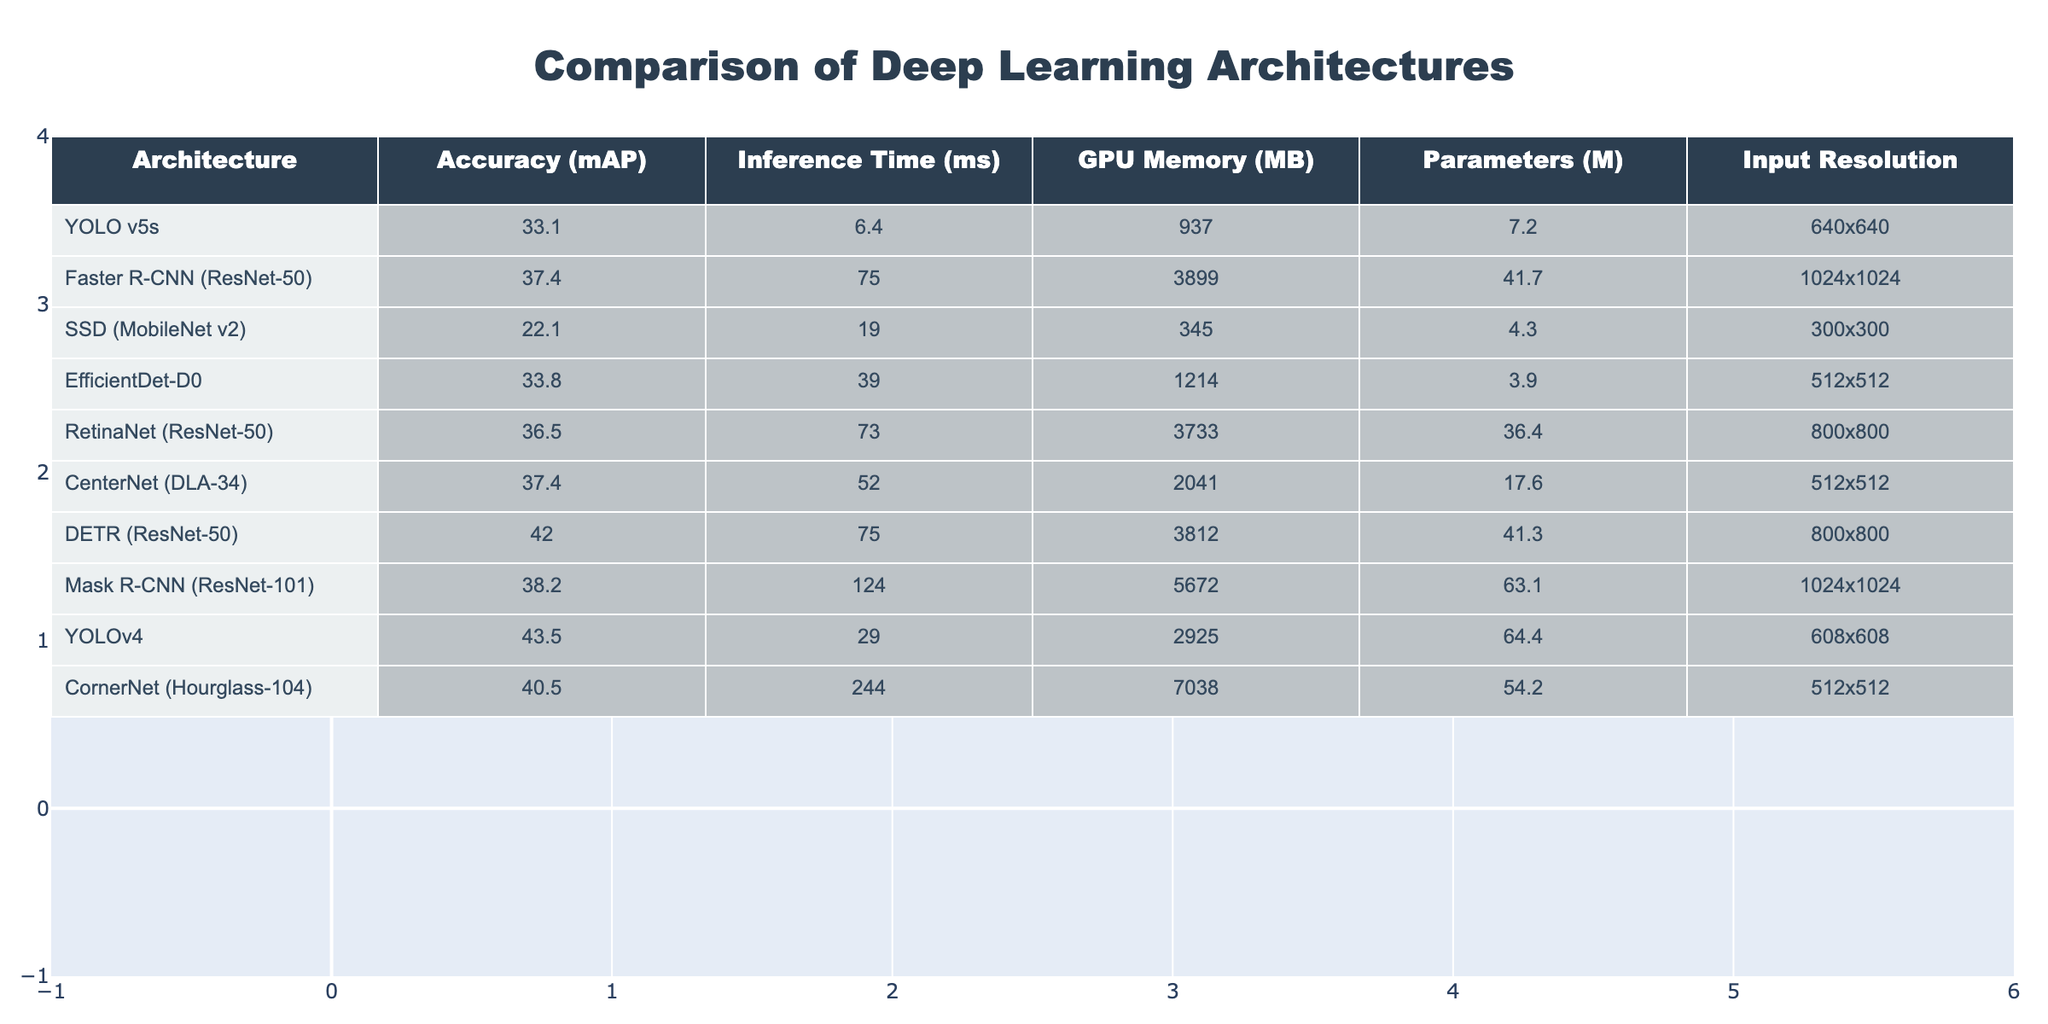What is the accuracy of YOLOv4? The table directly lists the accuracy for YOLOv4 as 43.5 mAP.
Answer: 43.5 Which architecture has the fastest inference time? By examining the 'Inference Time (ms)' column, YOLO v5s shows the lowest inference time of 6.4 ms compared to the other architectures.
Answer: YOLO v5s What is the range of GPU memory required among these architectures? The 'GPU Memory (MB)' column shows a minimum of 345 MB (SSD - MobileNet v2) and a maximum of 7038 MB (CornerNet - Hourglass-104), hence the range is 345 to 7038 MB.
Answer: 345 to 7038 MB How many architectures have an accuracy greater than 40? By referring to the 'Accuracy (mAP)' column, the architectures with accuracy greater than 40 are YOLOv4 (43.5), DETR (42.0), and CornerNet (40.5). Therefore, there are three such architectures.
Answer: 3 What is the average inference time for architectures with accuracy above 35? First, filter architectures with an accuracy above 35: Faster R-CNN (75.0), RetinaNet (73.0), CenterNet (52.0), MASK R-CNN (124.0), DECT (75.0), YOLOv4 (29.0) and exclude those below 35. The inference times for these are (75.0 + 73.0 + 52.0 + 75.0 + 29.0) = 304.0 ms and there are 5 architectures. The average is 304.0/5 = 60.8 ms.
Answer: 60.8 ms Is there any architecture with more than 60 million parameters? Considering the 'Parameters (M)' column, the only architecture with more than 60 million parameters is Mask R-CNN (ResNet-101), which has 63.1 M. Thus, the answer is yes.
Answer: Yes Which architecture achieves the best accuracy relative to its inference time? To identify the best accuracy relative to inference time, compare the accuracy to inference time ratios. YOLOv4 offers 43.5/29.0 = 1.5, while YOLO v5s (33.1/6.4 = 5.17) and others vary. YOLO v5s has a better ratio and provides higher efficiency in performance than others.
Answer: YOLO v5s What is the difference in accuracy between the best and the worst performing architectures? The best performing architecture is DECT with an accuracy of 42.0, and the worst is SSD (MobileNet v2) at 22.1. The difference is calculated as 42.0 - 22.1 = 19.9.
Answer: 19.9 How does the resolution impact the GPU memory needed across architectures? By closely inspecting the relationship between 'Input Resolution' and 'GPU Memory (MB)', we find that higher resolutions generally require more GPU memory. For instance, both Faster R-CNN and Mask R-CNN have the highest memory usage with resolutions of 1024x1024, while SSD with 300x300 uses significantly less memory. This indicates that higher input resolution tends to correlate with increased GPU memory needs.
Answer: Higher resolutions generally require more GPU memory 